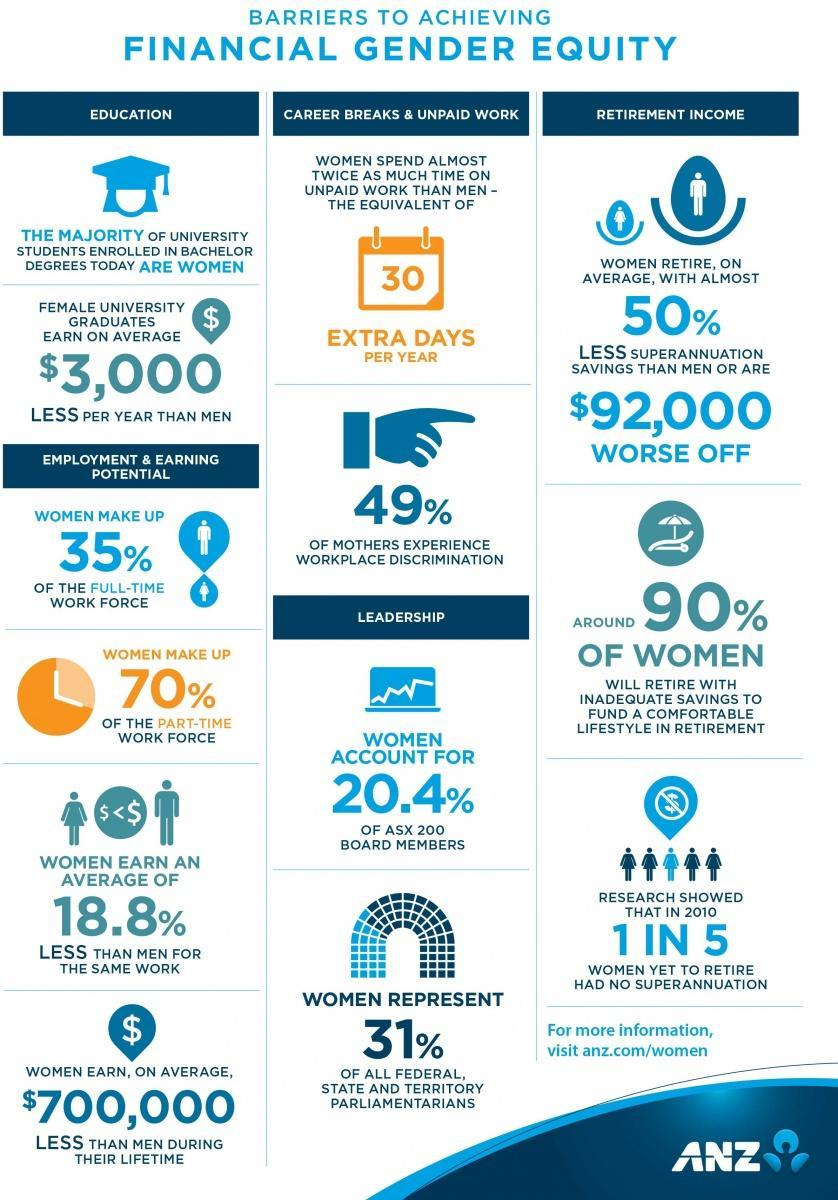What percentage of women, who are yet to retire, had no superannuation in 2010
Answer the question with a short phrase. 20% How much more do the men earn than women on an average for the same work? 18.8% 